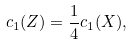Convert formula to latex. <formula><loc_0><loc_0><loc_500><loc_500>c _ { 1 } ( Z ) = \frac { 1 } { 4 } c _ { 1 } ( X ) ,</formula> 